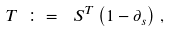Convert formula to latex. <formula><loc_0><loc_0><loc_500><loc_500>T \ \colon = \ \, S ^ { T } \left ( 1 - \partial _ { s } \right ) \, ,</formula> 